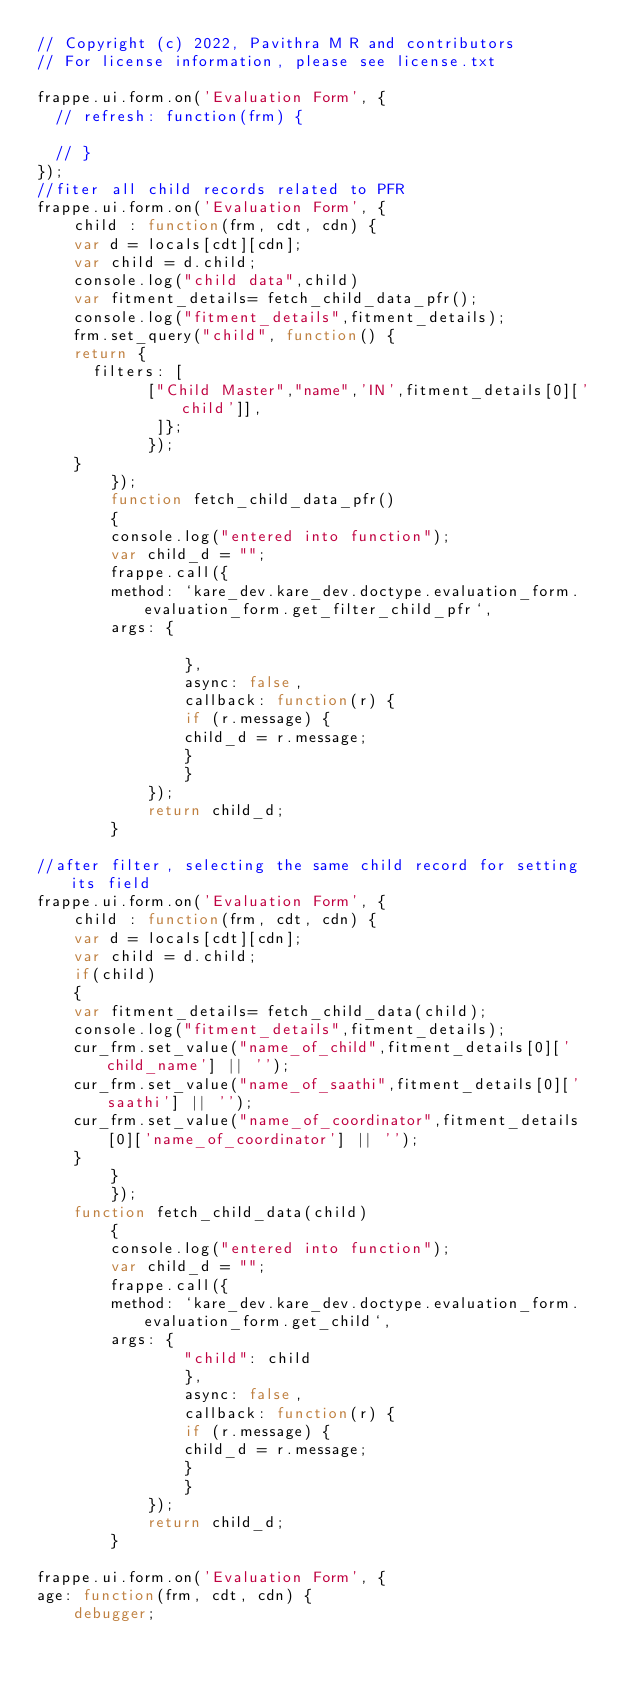<code> <loc_0><loc_0><loc_500><loc_500><_JavaScript_>// Copyright (c) 2022, Pavithra M R and contributors
// For license information, please see license.txt

frappe.ui.form.on('Evaluation Form', {
	// refresh: function(frm) {

	// }
});
//fiter all child records related to PFR 
frappe.ui.form.on('Evaluation Form', {
    child : function(frm, cdt, cdn) {
    var d = locals[cdt][cdn];
    var child = d.child;
    console.log("child data",child)
    var fitment_details= fetch_child_data_pfr();
    console.log("fitment_details",fitment_details);
    frm.set_query("child", function() {
    return {
      filters: [
            ["Child Master","name",'IN',fitment_details[0]['child']],
             ]};
            });
    }
        });
        function fetch_child_data_pfr()
        {
        console.log("entered into function");
        var child_d = "";
        frappe.call({
        method: `kare_dev.kare_dev.doctype.evaluation_form.evaluation_form.get_filter_child_pfr`,
        args: {
               
                },
                async: false,
                callback: function(r) {
                if (r.message) {
                child_d = r.message;
                }    
                }
            });
            return child_d;
        }

//after filter, selecting the same child record for setting its field
frappe.ui.form.on('Evaluation Form', {
    child : function(frm, cdt, cdn) {
    var d = locals[cdt][cdn];
    var child = d.child;
    if(child)
    {
    var fitment_details= fetch_child_data(child);
    console.log("fitment_details",fitment_details);
    cur_frm.set_value("name_of_child",fitment_details[0]['child_name'] || '');
    cur_frm.set_value("name_of_saathi",fitment_details[0]['saathi'] || '');
    cur_frm.set_value("name_of_coordinator",fitment_details[0]['name_of_coordinator'] || '');
    }
        }
        });
    function fetch_child_data(child)
        {
        console.log("entered into function");
        var child_d = "";
        frappe.call({
        method: `kare_dev.kare_dev.doctype.evaluation_form.evaluation_form.get_child`,
        args: {
                "child": child
                },
                async: false,
                callback: function(r) {
                if (r.message) {
                child_d = r.message;
                }    
                }
            });
            return child_d;
        }

frappe.ui.form.on('Evaluation Form', {
age: function(frm, cdt, cdn) {
    debugger;</code> 